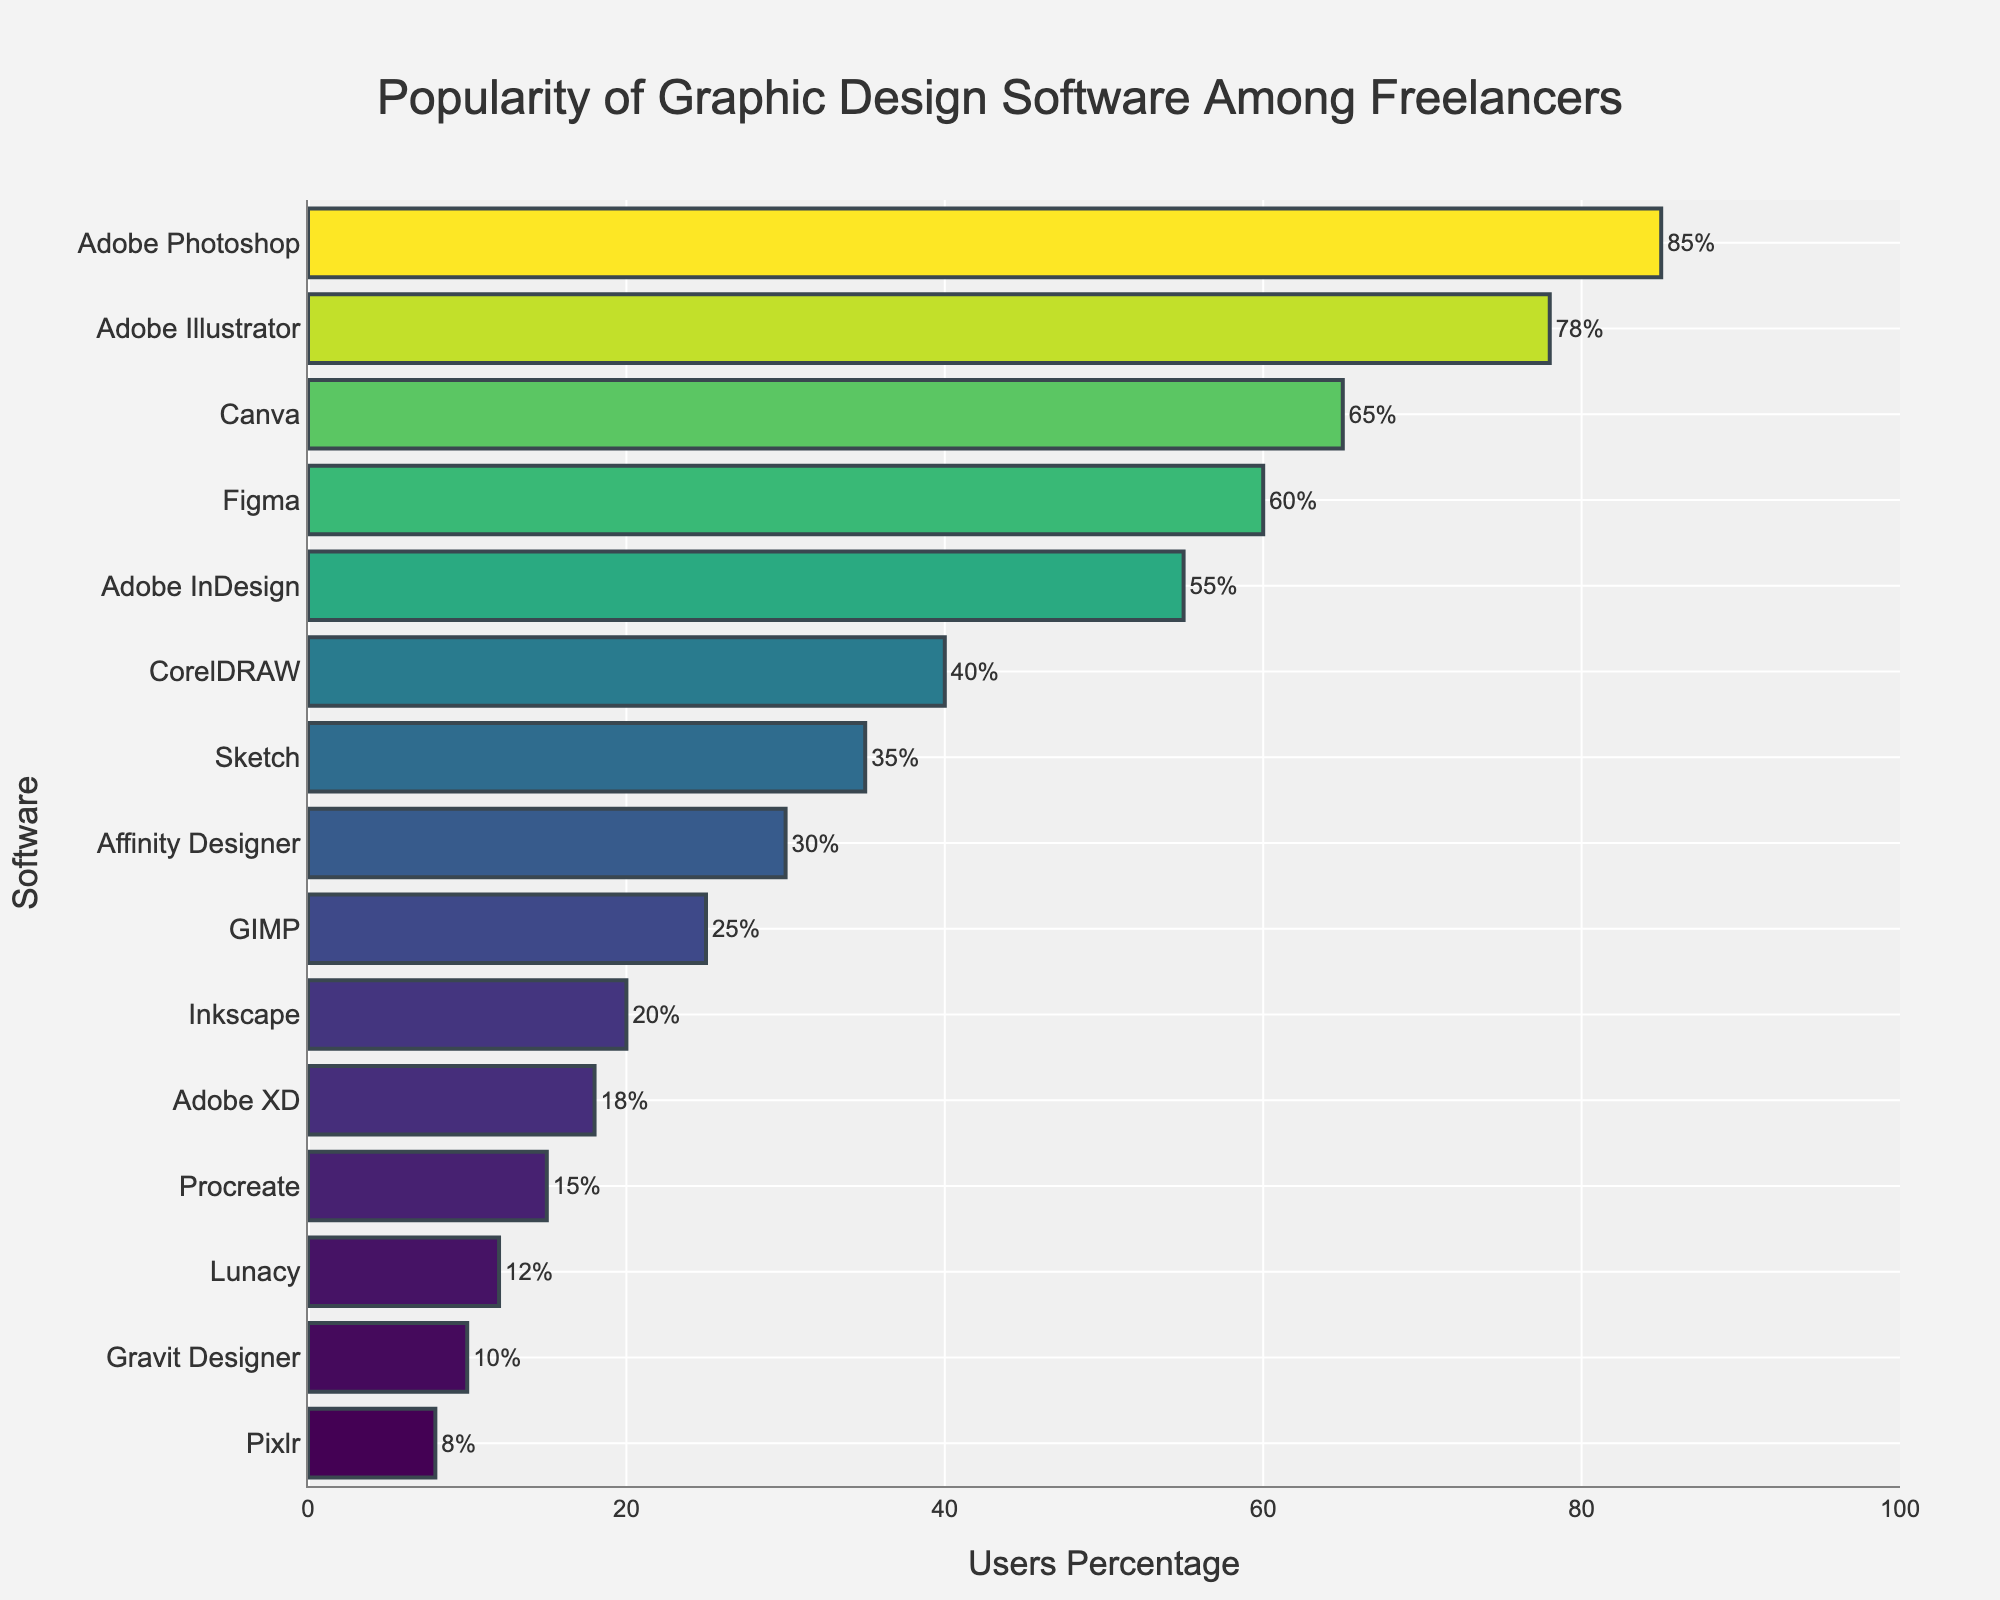Which software has the highest user percentage? The bar chart shows that Adobe Photoshop has the highest percentage of users.
Answer: Adobe Photoshop Which software has the lowest user percentage? The bar chart shows that Pixlr has the lowest percentage of users.
Answer: Pixlr How many software tools have a user percentage greater than 50%? Count the bars that have values greater than 50%. Adobe Photoshop, Adobe Illustrator, Canva, Figma, and Adobe InDesign each have a percentage greater than 50%.
Answer: 5 What is the combined user percentage of Adobe Illustrator and Figma? Add the user percentages of Adobe Illustrator (78%) and Figma (60%). 78 + 60 = 138.
Answer: 138% Which software has a user percentage closest to 35%? Among the bars, Sketch has a user percentage of 35%, which is the closest to 35% exactly.
Answer: Sketch What is the difference in user percentage between Canva and CorelDRAW? Subtract the user percentage of CorelDRAW (40%) from Canva (65%). 65 - 40 = 25.
Answer: 25% How does the user base of Affinity Designer compare to that of Sketch? From the bar chart, Sketch has 35% users and Affinity Designer has 30% users. Sketch has a higher user base than Affinity Designer.
Answer: Sketch has a higher user base Which software options have a user percentage between 20% and 30%? Identify the bars where the percentage falls between 20% and 30%. Affinity Designer (30%) and GIMP (25%) fall into this range.
Answer: Affinity Designer and GIMP By what percentage is Adobe Photoshop more popular than Procreate? Subtract the user percentage of Procreate (15%) from Adobe Photoshop (85%). 85 - 15 = 70.
Answer: 70% How does the usage of Inkscape compare to Lunacy? Inkscape has a user percentage of 20% and Lunacy has 12%. Inkscape has a higher user percentage than Lunacy.
Answer: Inkscape has a higher user percentage 